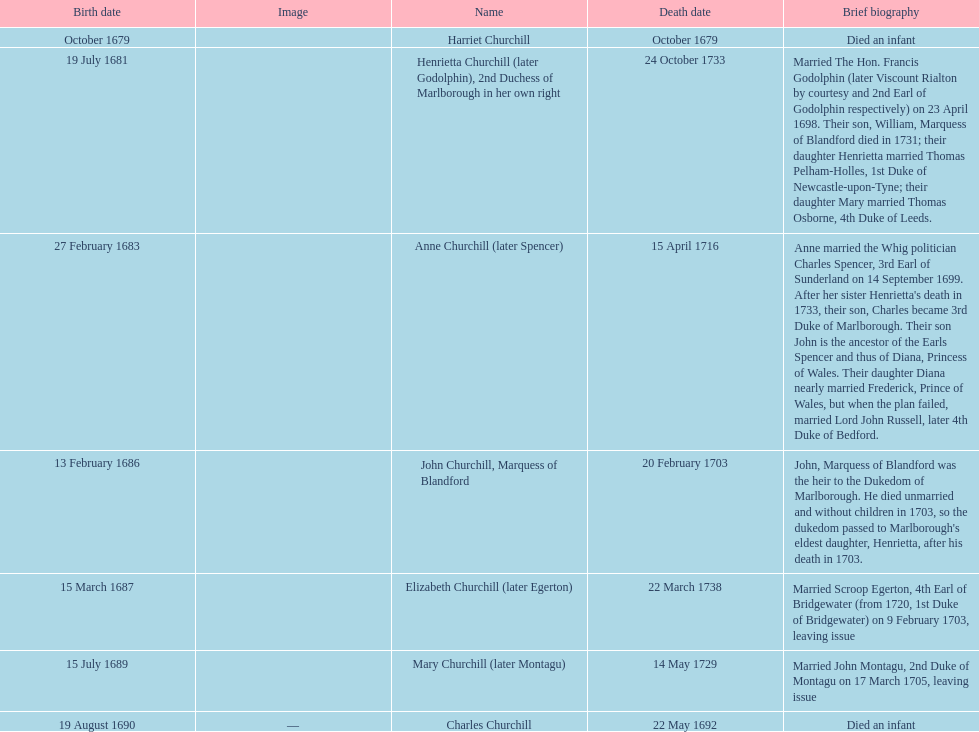How long did anne churchill/spencer live? 33. 